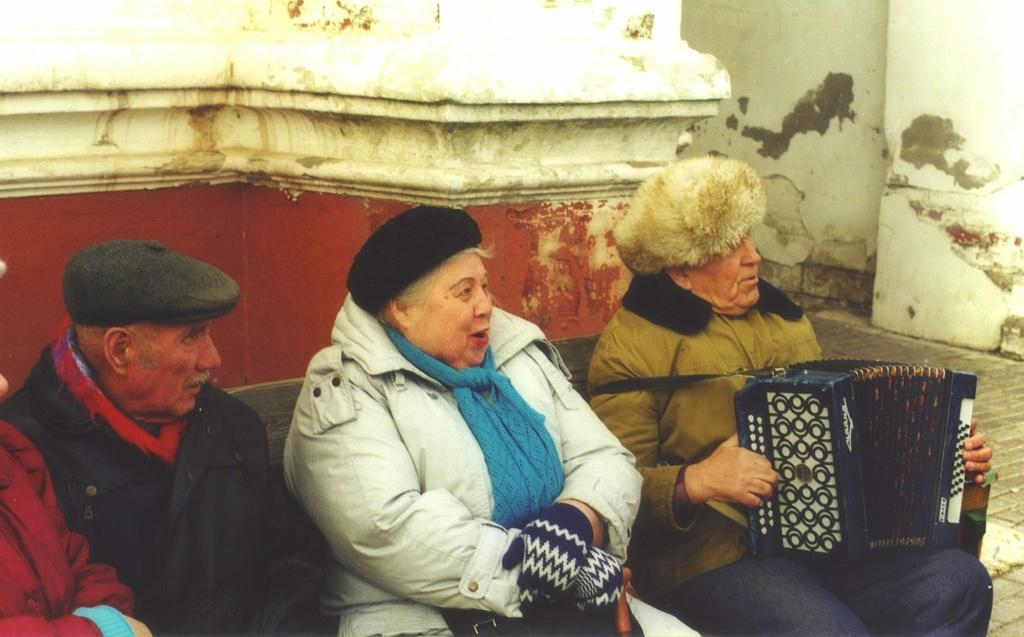What are the people in the image doing? The people in the image are sitting. What can be seen in the background of the image? There is a wall in the background of the image. What type of coal is being used to paint the canvas in the image? There is no coal or canvas present in the image; it only features people sitting and a wall in the background. 